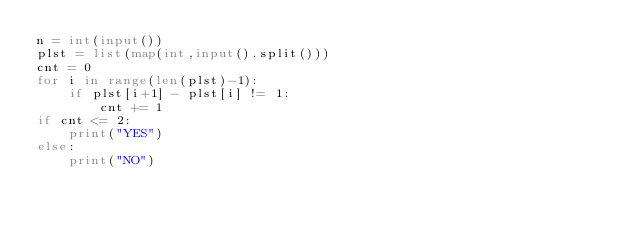Convert code to text. <code><loc_0><loc_0><loc_500><loc_500><_Python_>n = int(input())
plst = list(map(int,input().split()))
cnt = 0
for i in range(len(plst)-1):
    if plst[i+1] - plst[i] != 1:
        cnt += 1
if cnt <= 2:
    print("YES")
else:
    print("NO")</code> 